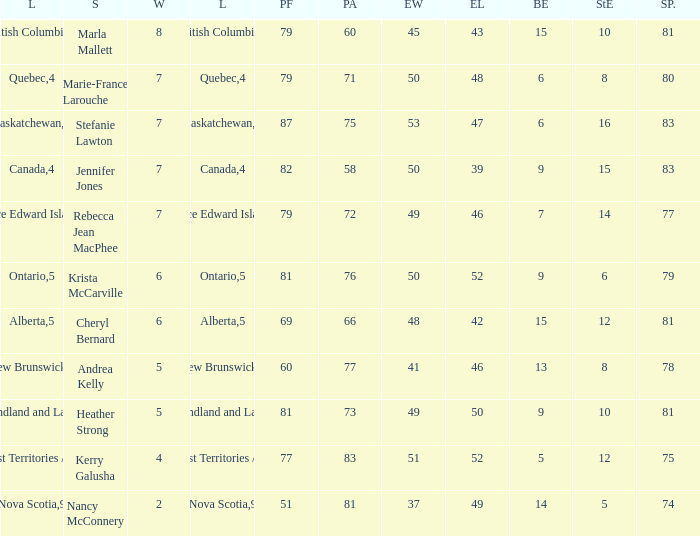What is the total of blank ends at Prince Edward Island? 7.0. 